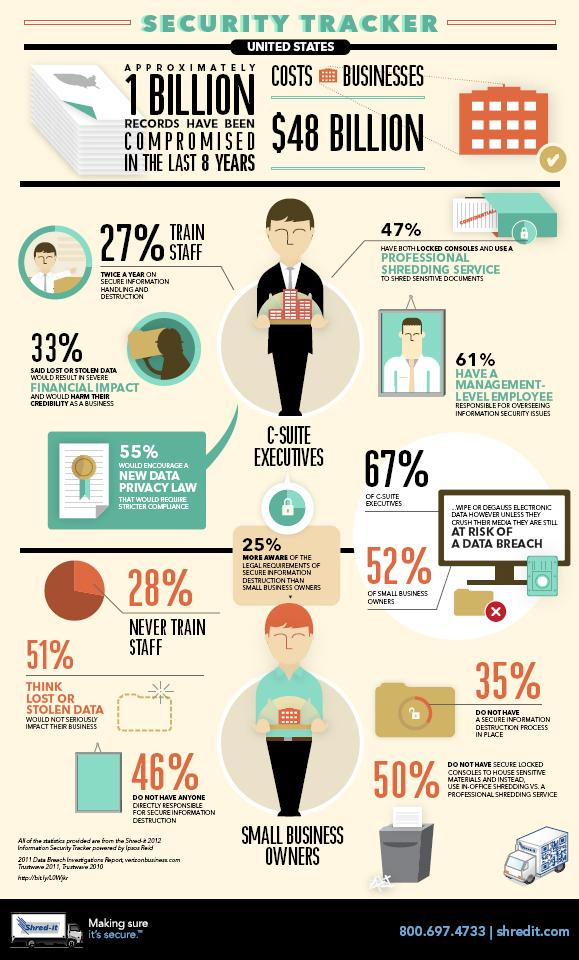Draw attention to some important aspects in this diagram. According to a recent survey, 45% of executives are not interested in a new data privacy law. According to a survey of small business owners, 49% believe that data theft has a significant impact on their business. According to the data, a significant percentage of executives, approximately 67%, do not believe that stolen data can have a financial impact. C-Suite executives are at a higher risk of experiencing a data breach compared to small business owners. A survey found that 39% of C-level executives do not have a management employee to oversee their company's information security issues. 